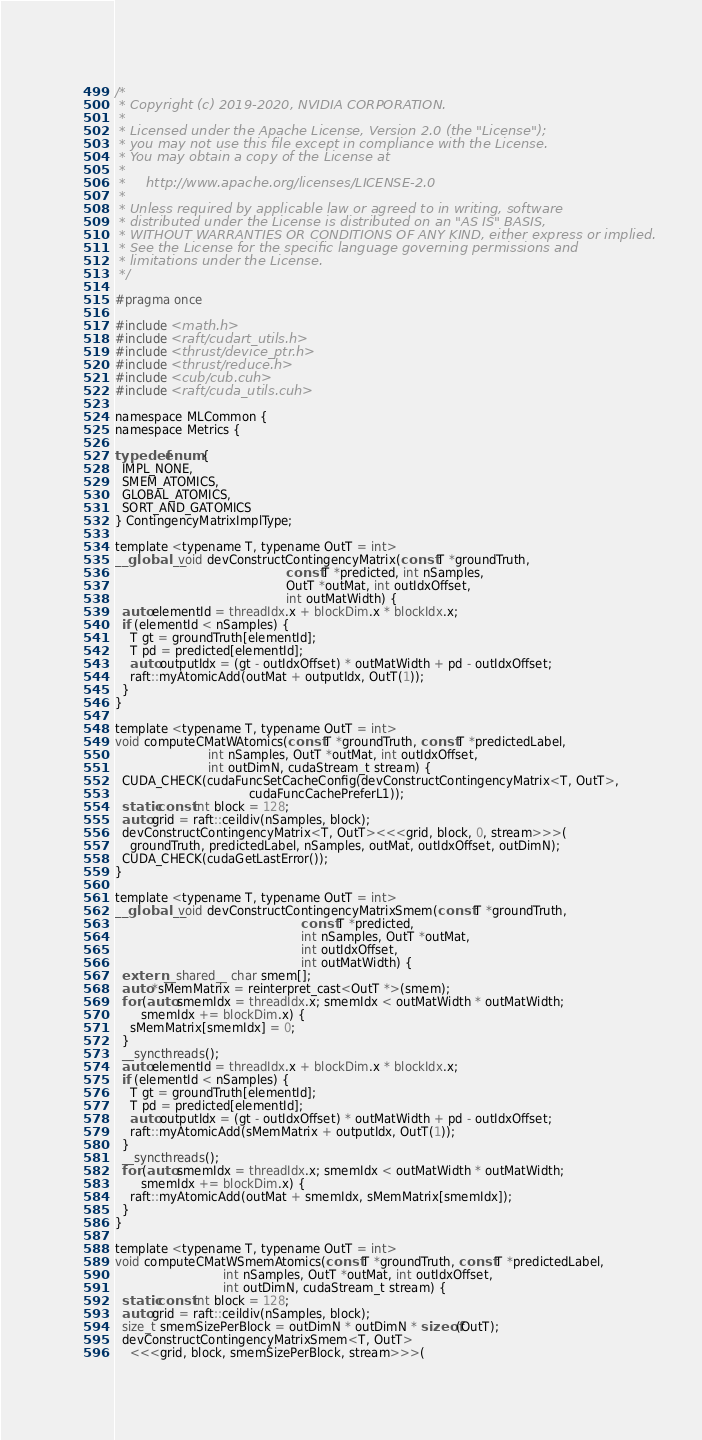Convert code to text. <code><loc_0><loc_0><loc_500><loc_500><_Cuda_>/*
 * Copyright (c) 2019-2020, NVIDIA CORPORATION.
 *
 * Licensed under the Apache License, Version 2.0 (the "License");
 * you may not use this file except in compliance with the License.
 * You may obtain a copy of the License at
 *
 *     http://www.apache.org/licenses/LICENSE-2.0
 *
 * Unless required by applicable law or agreed to in writing, software
 * distributed under the License is distributed on an "AS IS" BASIS,
 * WITHOUT WARRANTIES OR CONDITIONS OF ANY KIND, either express or implied.
 * See the License for the specific language governing permissions and
 * limitations under the License.
 */

#pragma once

#include <math.h>
#include <raft/cudart_utils.h>
#include <thrust/device_ptr.h>
#include <thrust/reduce.h>
#include <cub/cub.cuh>
#include <raft/cuda_utils.cuh>

namespace MLCommon {
namespace Metrics {

typedef enum {
  IMPL_NONE,
  SMEM_ATOMICS,
  GLOBAL_ATOMICS,
  SORT_AND_GATOMICS
} ContingencyMatrixImplType;

template <typename T, typename OutT = int>
__global__ void devConstructContingencyMatrix(const T *groundTruth,
                                              const T *predicted, int nSamples,
                                              OutT *outMat, int outIdxOffset,
                                              int outMatWidth) {
  auto elementId = threadIdx.x + blockDim.x * blockIdx.x;
  if (elementId < nSamples) {
    T gt = groundTruth[elementId];
    T pd = predicted[elementId];
    auto outputIdx = (gt - outIdxOffset) * outMatWidth + pd - outIdxOffset;
    raft::myAtomicAdd(outMat + outputIdx, OutT(1));
  }
}

template <typename T, typename OutT = int>
void computeCMatWAtomics(const T *groundTruth, const T *predictedLabel,
                         int nSamples, OutT *outMat, int outIdxOffset,
                         int outDimN, cudaStream_t stream) {
  CUDA_CHECK(cudaFuncSetCacheConfig(devConstructContingencyMatrix<T, OutT>,
                                    cudaFuncCachePreferL1));
  static const int block = 128;
  auto grid = raft::ceildiv(nSamples, block);
  devConstructContingencyMatrix<T, OutT><<<grid, block, 0, stream>>>(
    groundTruth, predictedLabel, nSamples, outMat, outIdxOffset, outDimN);
  CUDA_CHECK(cudaGetLastError());
}

template <typename T, typename OutT = int>
__global__ void devConstructContingencyMatrixSmem(const T *groundTruth,
                                                  const T *predicted,
                                                  int nSamples, OutT *outMat,
                                                  int outIdxOffset,
                                                  int outMatWidth) {
  extern __shared__ char smem[];
  auto *sMemMatrix = reinterpret_cast<OutT *>(smem);
  for (auto smemIdx = threadIdx.x; smemIdx < outMatWidth * outMatWidth;
       smemIdx += blockDim.x) {
    sMemMatrix[smemIdx] = 0;
  }
  __syncthreads();
  auto elementId = threadIdx.x + blockDim.x * blockIdx.x;
  if (elementId < nSamples) {
    T gt = groundTruth[elementId];
    T pd = predicted[elementId];
    auto outputIdx = (gt - outIdxOffset) * outMatWidth + pd - outIdxOffset;
    raft::myAtomicAdd(sMemMatrix + outputIdx, OutT(1));
  }
  __syncthreads();
  for (auto smemIdx = threadIdx.x; smemIdx < outMatWidth * outMatWidth;
       smemIdx += blockDim.x) {
    raft::myAtomicAdd(outMat + smemIdx, sMemMatrix[smemIdx]);
  }
}

template <typename T, typename OutT = int>
void computeCMatWSmemAtomics(const T *groundTruth, const T *predictedLabel,
                             int nSamples, OutT *outMat, int outIdxOffset,
                             int outDimN, cudaStream_t stream) {
  static const int block = 128;
  auto grid = raft::ceildiv(nSamples, block);
  size_t smemSizePerBlock = outDimN * outDimN * sizeof(OutT);
  devConstructContingencyMatrixSmem<T, OutT>
    <<<grid, block, smemSizePerBlock, stream>>>(</code> 